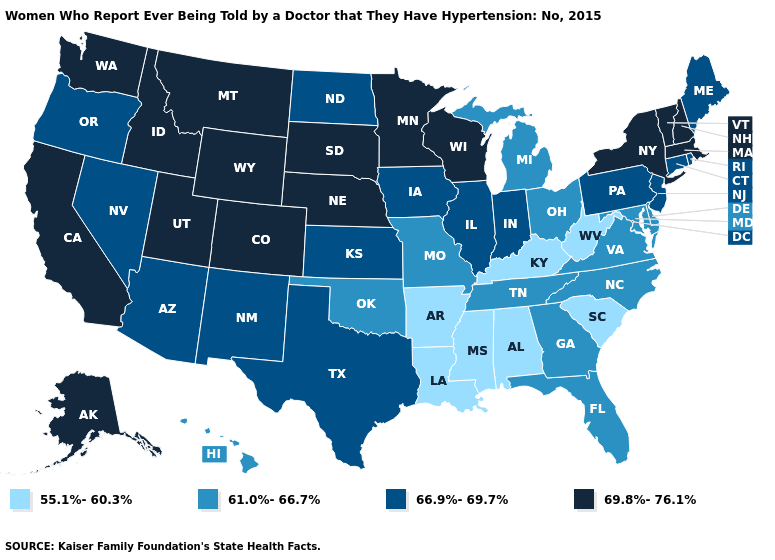What is the value of Nebraska?
Short answer required. 69.8%-76.1%. Does the first symbol in the legend represent the smallest category?
Answer briefly. Yes. Name the states that have a value in the range 69.8%-76.1%?
Answer briefly. Alaska, California, Colorado, Idaho, Massachusetts, Minnesota, Montana, Nebraska, New Hampshire, New York, South Dakota, Utah, Vermont, Washington, Wisconsin, Wyoming. Name the states that have a value in the range 66.9%-69.7%?
Be succinct. Arizona, Connecticut, Illinois, Indiana, Iowa, Kansas, Maine, Nevada, New Jersey, New Mexico, North Dakota, Oregon, Pennsylvania, Rhode Island, Texas. Name the states that have a value in the range 55.1%-60.3%?
Concise answer only. Alabama, Arkansas, Kentucky, Louisiana, Mississippi, South Carolina, West Virginia. Among the states that border Louisiana , does Texas have the lowest value?
Keep it brief. No. Does New York have the lowest value in the Northeast?
Write a very short answer. No. What is the value of South Carolina?
Concise answer only. 55.1%-60.3%. Name the states that have a value in the range 69.8%-76.1%?
Be succinct. Alaska, California, Colorado, Idaho, Massachusetts, Minnesota, Montana, Nebraska, New Hampshire, New York, South Dakota, Utah, Vermont, Washington, Wisconsin, Wyoming. Name the states that have a value in the range 66.9%-69.7%?
Answer briefly. Arizona, Connecticut, Illinois, Indiana, Iowa, Kansas, Maine, Nevada, New Jersey, New Mexico, North Dakota, Oregon, Pennsylvania, Rhode Island, Texas. Does the map have missing data?
Short answer required. No. What is the value of Illinois?
Answer briefly. 66.9%-69.7%. Does New Hampshire have the highest value in the Northeast?
Write a very short answer. Yes. What is the value of Wyoming?
Be succinct. 69.8%-76.1%. What is the highest value in the West ?
Keep it brief. 69.8%-76.1%. 